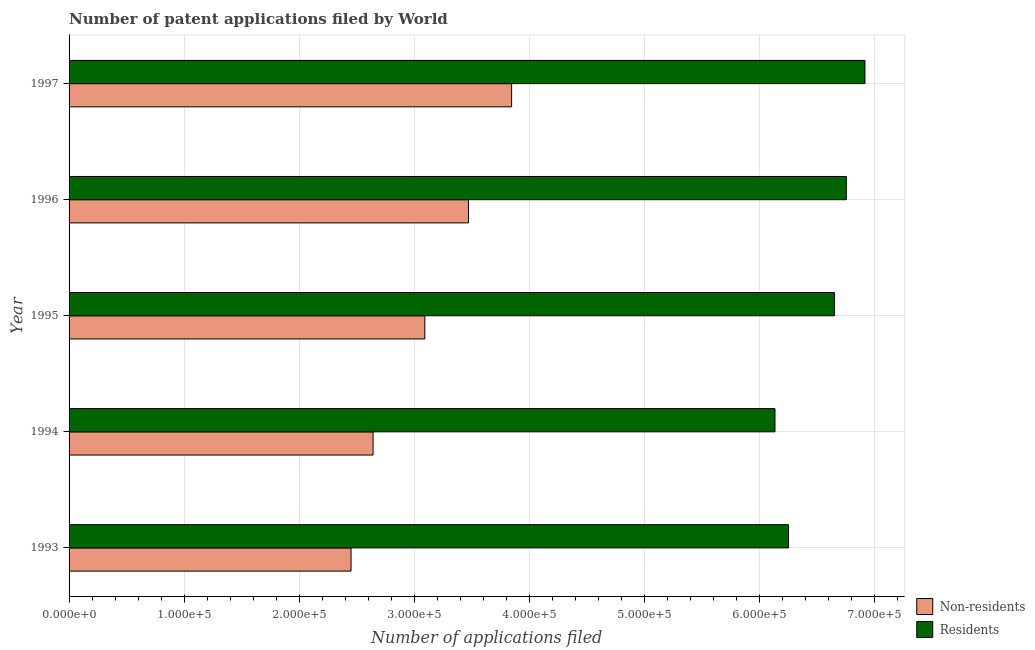How many groups of bars are there?
Make the answer very short. 5. Are the number of bars per tick equal to the number of legend labels?
Ensure brevity in your answer.  Yes. Are the number of bars on each tick of the Y-axis equal?
Keep it short and to the point. Yes. How many bars are there on the 4th tick from the top?
Make the answer very short. 2. What is the label of the 1st group of bars from the top?
Provide a succinct answer. 1997. In how many cases, is the number of bars for a given year not equal to the number of legend labels?
Give a very brief answer. 0. What is the number of patent applications by non residents in 1996?
Provide a succinct answer. 3.47e+05. Across all years, what is the maximum number of patent applications by residents?
Give a very brief answer. 6.92e+05. Across all years, what is the minimum number of patent applications by residents?
Give a very brief answer. 6.13e+05. What is the total number of patent applications by non residents in the graph?
Keep it short and to the point. 1.55e+06. What is the difference between the number of patent applications by non residents in 1993 and that in 1997?
Offer a terse response. -1.40e+05. What is the difference between the number of patent applications by non residents in 1995 and the number of patent applications by residents in 1996?
Give a very brief answer. -3.66e+05. What is the average number of patent applications by residents per year?
Offer a very short reply. 6.54e+05. In the year 1997, what is the difference between the number of patent applications by non residents and number of patent applications by residents?
Offer a very short reply. -3.07e+05. What is the ratio of the number of patent applications by residents in 1995 to that in 1996?
Your response must be concise. 0.98. Is the number of patent applications by residents in 1993 less than that in 1997?
Your answer should be compact. Yes. Is the difference between the number of patent applications by non residents in 1993 and 1997 greater than the difference between the number of patent applications by residents in 1993 and 1997?
Ensure brevity in your answer.  No. What is the difference between the highest and the second highest number of patent applications by non residents?
Your response must be concise. 3.75e+04. What is the difference between the highest and the lowest number of patent applications by non residents?
Make the answer very short. 1.40e+05. In how many years, is the number of patent applications by residents greater than the average number of patent applications by residents taken over all years?
Your answer should be very brief. 3. Is the sum of the number of patent applications by residents in 1993 and 1996 greater than the maximum number of patent applications by non residents across all years?
Your answer should be compact. Yes. What does the 2nd bar from the top in 1994 represents?
Make the answer very short. Non-residents. What does the 1st bar from the bottom in 1996 represents?
Keep it short and to the point. Non-residents. Are all the bars in the graph horizontal?
Your answer should be very brief. Yes. How many years are there in the graph?
Provide a short and direct response. 5. What is the difference between two consecutive major ticks on the X-axis?
Provide a succinct answer. 1.00e+05. Does the graph contain any zero values?
Provide a succinct answer. No. How many legend labels are there?
Give a very brief answer. 2. How are the legend labels stacked?
Provide a succinct answer. Vertical. What is the title of the graph?
Offer a terse response. Number of patent applications filed by World. What is the label or title of the X-axis?
Your answer should be very brief. Number of applications filed. What is the Number of applications filed in Non-residents in 1993?
Your response must be concise. 2.45e+05. What is the Number of applications filed in Residents in 1993?
Offer a very short reply. 6.25e+05. What is the Number of applications filed of Non-residents in 1994?
Your response must be concise. 2.64e+05. What is the Number of applications filed in Residents in 1994?
Give a very brief answer. 6.13e+05. What is the Number of applications filed of Non-residents in 1995?
Ensure brevity in your answer.  3.09e+05. What is the Number of applications filed in Residents in 1995?
Provide a succinct answer. 6.65e+05. What is the Number of applications filed in Non-residents in 1996?
Your answer should be compact. 3.47e+05. What is the Number of applications filed of Residents in 1996?
Keep it short and to the point. 6.75e+05. What is the Number of applications filed of Non-residents in 1997?
Offer a very short reply. 3.85e+05. What is the Number of applications filed of Residents in 1997?
Offer a very short reply. 6.92e+05. Across all years, what is the maximum Number of applications filed of Non-residents?
Make the answer very short. 3.85e+05. Across all years, what is the maximum Number of applications filed in Residents?
Keep it short and to the point. 6.92e+05. Across all years, what is the minimum Number of applications filed in Non-residents?
Make the answer very short. 2.45e+05. Across all years, what is the minimum Number of applications filed of Residents?
Provide a succinct answer. 6.13e+05. What is the total Number of applications filed of Non-residents in the graph?
Provide a short and direct response. 1.55e+06. What is the total Number of applications filed in Residents in the graph?
Offer a very short reply. 3.27e+06. What is the difference between the Number of applications filed in Non-residents in 1993 and that in 1994?
Keep it short and to the point. -1.91e+04. What is the difference between the Number of applications filed in Residents in 1993 and that in 1994?
Provide a short and direct response. 1.18e+04. What is the difference between the Number of applications filed in Non-residents in 1993 and that in 1995?
Offer a terse response. -6.41e+04. What is the difference between the Number of applications filed of Residents in 1993 and that in 1995?
Keep it short and to the point. -3.99e+04. What is the difference between the Number of applications filed of Non-residents in 1993 and that in 1996?
Ensure brevity in your answer.  -1.02e+05. What is the difference between the Number of applications filed of Residents in 1993 and that in 1996?
Provide a succinct answer. -5.02e+04. What is the difference between the Number of applications filed of Non-residents in 1993 and that in 1997?
Your response must be concise. -1.40e+05. What is the difference between the Number of applications filed in Residents in 1993 and that in 1997?
Offer a very short reply. -6.64e+04. What is the difference between the Number of applications filed of Non-residents in 1994 and that in 1995?
Provide a short and direct response. -4.50e+04. What is the difference between the Number of applications filed in Residents in 1994 and that in 1995?
Your answer should be very brief. -5.16e+04. What is the difference between the Number of applications filed of Non-residents in 1994 and that in 1996?
Give a very brief answer. -8.29e+04. What is the difference between the Number of applications filed in Residents in 1994 and that in 1996?
Offer a terse response. -6.20e+04. What is the difference between the Number of applications filed in Non-residents in 1994 and that in 1997?
Provide a succinct answer. -1.20e+05. What is the difference between the Number of applications filed in Residents in 1994 and that in 1997?
Offer a terse response. -7.82e+04. What is the difference between the Number of applications filed in Non-residents in 1995 and that in 1996?
Provide a succinct answer. -3.79e+04. What is the difference between the Number of applications filed in Residents in 1995 and that in 1996?
Keep it short and to the point. -1.03e+04. What is the difference between the Number of applications filed of Non-residents in 1995 and that in 1997?
Give a very brief answer. -7.54e+04. What is the difference between the Number of applications filed in Residents in 1995 and that in 1997?
Provide a succinct answer. -2.65e+04. What is the difference between the Number of applications filed of Non-residents in 1996 and that in 1997?
Make the answer very short. -3.75e+04. What is the difference between the Number of applications filed in Residents in 1996 and that in 1997?
Give a very brief answer. -1.62e+04. What is the difference between the Number of applications filed in Non-residents in 1993 and the Number of applications filed in Residents in 1994?
Give a very brief answer. -3.68e+05. What is the difference between the Number of applications filed of Non-residents in 1993 and the Number of applications filed of Residents in 1995?
Your response must be concise. -4.20e+05. What is the difference between the Number of applications filed of Non-residents in 1993 and the Number of applications filed of Residents in 1996?
Your response must be concise. -4.30e+05. What is the difference between the Number of applications filed in Non-residents in 1993 and the Number of applications filed in Residents in 1997?
Provide a short and direct response. -4.47e+05. What is the difference between the Number of applications filed in Non-residents in 1994 and the Number of applications filed in Residents in 1995?
Your answer should be compact. -4.01e+05. What is the difference between the Number of applications filed of Non-residents in 1994 and the Number of applications filed of Residents in 1996?
Ensure brevity in your answer.  -4.11e+05. What is the difference between the Number of applications filed in Non-residents in 1994 and the Number of applications filed in Residents in 1997?
Provide a succinct answer. -4.27e+05. What is the difference between the Number of applications filed of Non-residents in 1995 and the Number of applications filed of Residents in 1996?
Make the answer very short. -3.66e+05. What is the difference between the Number of applications filed in Non-residents in 1995 and the Number of applications filed in Residents in 1997?
Make the answer very short. -3.82e+05. What is the difference between the Number of applications filed in Non-residents in 1996 and the Number of applications filed in Residents in 1997?
Offer a terse response. -3.45e+05. What is the average Number of applications filed of Non-residents per year?
Provide a short and direct response. 3.10e+05. What is the average Number of applications filed of Residents per year?
Your response must be concise. 6.54e+05. In the year 1993, what is the difference between the Number of applications filed of Non-residents and Number of applications filed of Residents?
Provide a short and direct response. -3.80e+05. In the year 1994, what is the difference between the Number of applications filed in Non-residents and Number of applications filed in Residents?
Provide a short and direct response. -3.49e+05. In the year 1995, what is the difference between the Number of applications filed in Non-residents and Number of applications filed in Residents?
Give a very brief answer. -3.56e+05. In the year 1996, what is the difference between the Number of applications filed in Non-residents and Number of applications filed in Residents?
Ensure brevity in your answer.  -3.28e+05. In the year 1997, what is the difference between the Number of applications filed of Non-residents and Number of applications filed of Residents?
Ensure brevity in your answer.  -3.07e+05. What is the ratio of the Number of applications filed of Non-residents in 1993 to that in 1994?
Offer a very short reply. 0.93. What is the ratio of the Number of applications filed in Residents in 1993 to that in 1994?
Offer a terse response. 1.02. What is the ratio of the Number of applications filed in Non-residents in 1993 to that in 1995?
Offer a very short reply. 0.79. What is the ratio of the Number of applications filed of Residents in 1993 to that in 1995?
Offer a terse response. 0.94. What is the ratio of the Number of applications filed of Non-residents in 1993 to that in 1996?
Your answer should be compact. 0.71. What is the ratio of the Number of applications filed in Residents in 1993 to that in 1996?
Provide a succinct answer. 0.93. What is the ratio of the Number of applications filed in Non-residents in 1993 to that in 1997?
Your answer should be very brief. 0.64. What is the ratio of the Number of applications filed of Residents in 1993 to that in 1997?
Give a very brief answer. 0.9. What is the ratio of the Number of applications filed of Non-residents in 1994 to that in 1995?
Your answer should be very brief. 0.85. What is the ratio of the Number of applications filed of Residents in 1994 to that in 1995?
Keep it short and to the point. 0.92. What is the ratio of the Number of applications filed of Non-residents in 1994 to that in 1996?
Your response must be concise. 0.76. What is the ratio of the Number of applications filed of Residents in 1994 to that in 1996?
Give a very brief answer. 0.91. What is the ratio of the Number of applications filed of Non-residents in 1994 to that in 1997?
Give a very brief answer. 0.69. What is the ratio of the Number of applications filed of Residents in 1994 to that in 1997?
Your response must be concise. 0.89. What is the ratio of the Number of applications filed in Non-residents in 1995 to that in 1996?
Your answer should be compact. 0.89. What is the ratio of the Number of applications filed in Residents in 1995 to that in 1996?
Make the answer very short. 0.98. What is the ratio of the Number of applications filed of Non-residents in 1995 to that in 1997?
Your answer should be compact. 0.8. What is the ratio of the Number of applications filed in Residents in 1995 to that in 1997?
Your answer should be compact. 0.96. What is the ratio of the Number of applications filed in Non-residents in 1996 to that in 1997?
Ensure brevity in your answer.  0.9. What is the ratio of the Number of applications filed of Residents in 1996 to that in 1997?
Offer a very short reply. 0.98. What is the difference between the highest and the second highest Number of applications filed of Non-residents?
Ensure brevity in your answer.  3.75e+04. What is the difference between the highest and the second highest Number of applications filed of Residents?
Give a very brief answer. 1.62e+04. What is the difference between the highest and the lowest Number of applications filed of Non-residents?
Your answer should be compact. 1.40e+05. What is the difference between the highest and the lowest Number of applications filed of Residents?
Offer a terse response. 7.82e+04. 